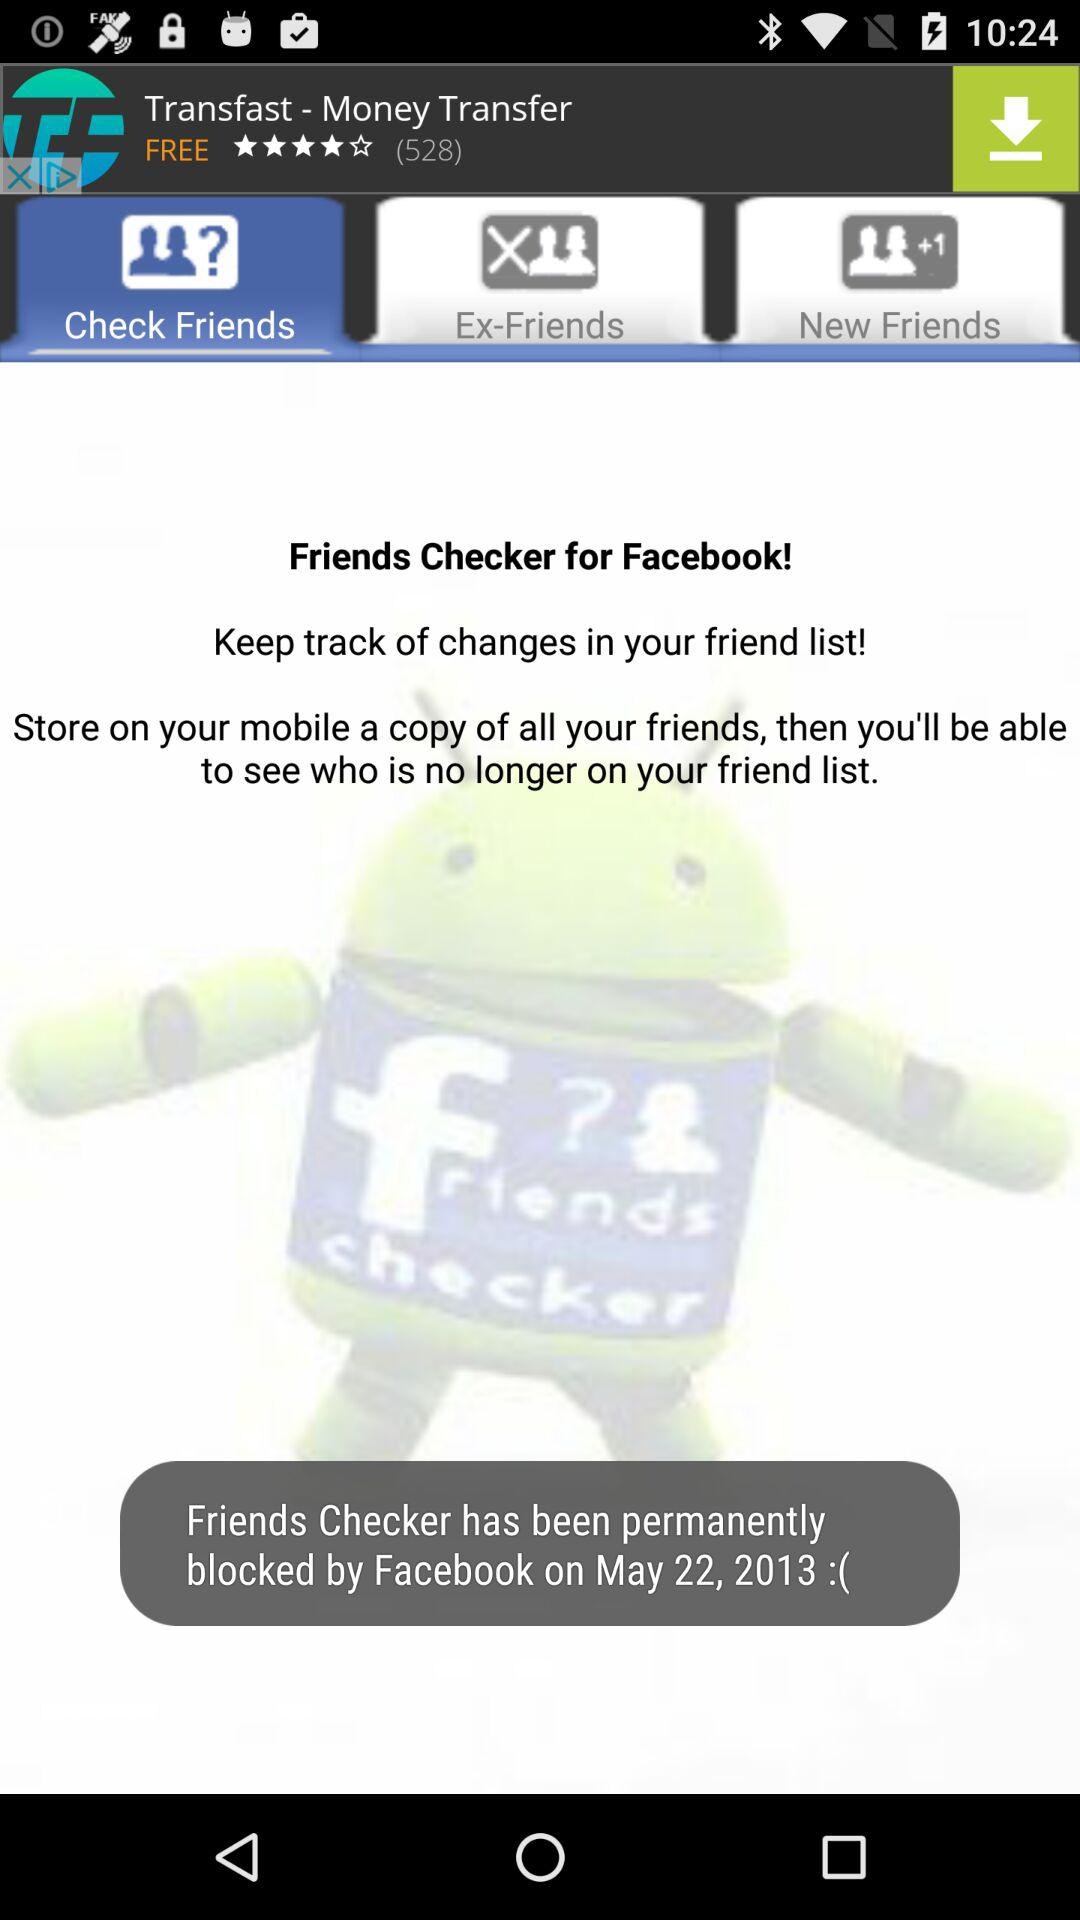Which tab is selected? The selected tab is "Check Friends". 